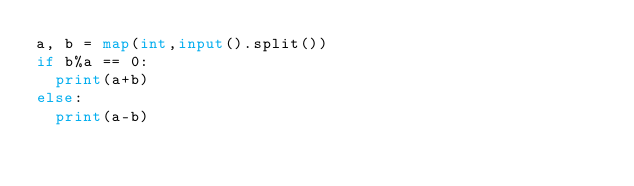Convert code to text. <code><loc_0><loc_0><loc_500><loc_500><_Python_>a, b = map(int,input().split())
if b%a == 0:
  print(a+b)
else:
  print(a-b)</code> 